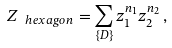Convert formula to latex. <formula><loc_0><loc_0><loc_500><loc_500>Z _ { \ h e x a g o n } = \sum _ { \{ D \} } z _ { 1 } ^ { n _ { 1 } } z _ { 2 } ^ { n _ { 2 } } \, ,</formula> 